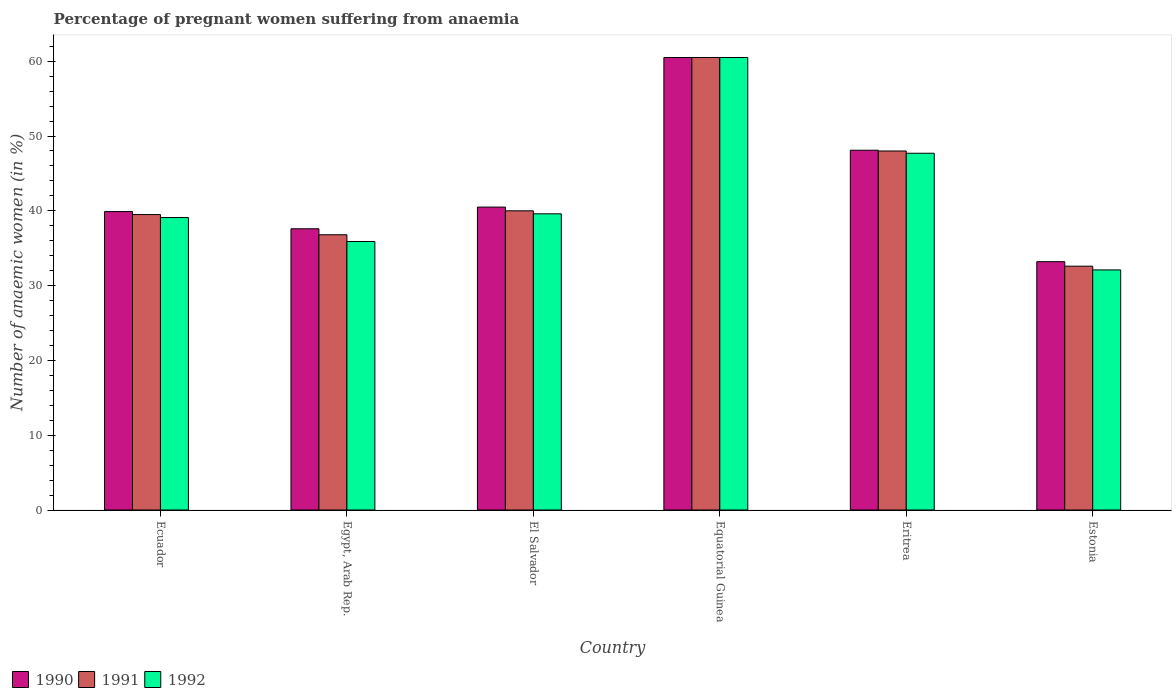How many different coloured bars are there?
Provide a short and direct response. 3. Are the number of bars per tick equal to the number of legend labels?
Ensure brevity in your answer.  Yes. Are the number of bars on each tick of the X-axis equal?
Provide a succinct answer. Yes. How many bars are there on the 2nd tick from the right?
Your response must be concise. 3. What is the label of the 3rd group of bars from the left?
Offer a very short reply. El Salvador. What is the number of anaemic women in 1991 in Egypt, Arab Rep.?
Make the answer very short. 36.8. Across all countries, what is the maximum number of anaemic women in 1992?
Your answer should be compact. 60.5. Across all countries, what is the minimum number of anaemic women in 1992?
Your answer should be compact. 32.1. In which country was the number of anaemic women in 1992 maximum?
Keep it short and to the point. Equatorial Guinea. In which country was the number of anaemic women in 1990 minimum?
Give a very brief answer. Estonia. What is the total number of anaemic women in 1990 in the graph?
Keep it short and to the point. 259.8. What is the difference between the number of anaemic women in 1990 in Ecuador and that in Eritrea?
Provide a succinct answer. -8.2. What is the difference between the number of anaemic women in 1992 in El Salvador and the number of anaemic women in 1991 in Egypt, Arab Rep.?
Make the answer very short. 2.8. What is the average number of anaemic women in 1990 per country?
Your answer should be very brief. 43.3. What is the difference between the number of anaemic women of/in 1990 and number of anaemic women of/in 1992 in Equatorial Guinea?
Your response must be concise. 0. In how many countries, is the number of anaemic women in 1991 greater than 42 %?
Provide a succinct answer. 2. What is the ratio of the number of anaemic women in 1992 in Ecuador to that in Eritrea?
Keep it short and to the point. 0.82. Is the difference between the number of anaemic women in 1990 in Ecuador and Egypt, Arab Rep. greater than the difference between the number of anaemic women in 1992 in Ecuador and Egypt, Arab Rep.?
Give a very brief answer. No. What is the difference between the highest and the second highest number of anaemic women in 1990?
Give a very brief answer. 7.6. What is the difference between the highest and the lowest number of anaemic women in 1991?
Offer a very short reply. 27.9. Is the sum of the number of anaemic women in 1992 in Eritrea and Estonia greater than the maximum number of anaemic women in 1990 across all countries?
Provide a short and direct response. Yes. What does the 1st bar from the left in Egypt, Arab Rep. represents?
Offer a very short reply. 1990. Is it the case that in every country, the sum of the number of anaemic women in 1992 and number of anaemic women in 1991 is greater than the number of anaemic women in 1990?
Make the answer very short. Yes. How many bars are there?
Make the answer very short. 18. What is the difference between two consecutive major ticks on the Y-axis?
Ensure brevity in your answer.  10. Are the values on the major ticks of Y-axis written in scientific E-notation?
Offer a very short reply. No. How many legend labels are there?
Your answer should be compact. 3. What is the title of the graph?
Provide a succinct answer. Percentage of pregnant women suffering from anaemia. Does "1988" appear as one of the legend labels in the graph?
Give a very brief answer. No. What is the label or title of the X-axis?
Your answer should be very brief. Country. What is the label or title of the Y-axis?
Your answer should be very brief. Number of anaemic women (in %). What is the Number of anaemic women (in %) of 1990 in Ecuador?
Offer a very short reply. 39.9. What is the Number of anaemic women (in %) in 1991 in Ecuador?
Give a very brief answer. 39.5. What is the Number of anaemic women (in %) in 1992 in Ecuador?
Offer a very short reply. 39.1. What is the Number of anaemic women (in %) in 1990 in Egypt, Arab Rep.?
Your response must be concise. 37.6. What is the Number of anaemic women (in %) of 1991 in Egypt, Arab Rep.?
Offer a terse response. 36.8. What is the Number of anaemic women (in %) of 1992 in Egypt, Arab Rep.?
Provide a short and direct response. 35.9. What is the Number of anaemic women (in %) of 1990 in El Salvador?
Ensure brevity in your answer.  40.5. What is the Number of anaemic women (in %) of 1991 in El Salvador?
Your response must be concise. 40. What is the Number of anaemic women (in %) in 1992 in El Salvador?
Give a very brief answer. 39.6. What is the Number of anaemic women (in %) of 1990 in Equatorial Guinea?
Ensure brevity in your answer.  60.5. What is the Number of anaemic women (in %) in 1991 in Equatorial Guinea?
Provide a short and direct response. 60.5. What is the Number of anaemic women (in %) of 1992 in Equatorial Guinea?
Give a very brief answer. 60.5. What is the Number of anaemic women (in %) in 1990 in Eritrea?
Your response must be concise. 48.1. What is the Number of anaemic women (in %) in 1991 in Eritrea?
Provide a short and direct response. 48. What is the Number of anaemic women (in %) of 1992 in Eritrea?
Ensure brevity in your answer.  47.7. What is the Number of anaemic women (in %) of 1990 in Estonia?
Provide a succinct answer. 33.2. What is the Number of anaemic women (in %) in 1991 in Estonia?
Give a very brief answer. 32.6. What is the Number of anaemic women (in %) in 1992 in Estonia?
Give a very brief answer. 32.1. Across all countries, what is the maximum Number of anaemic women (in %) of 1990?
Your answer should be compact. 60.5. Across all countries, what is the maximum Number of anaemic women (in %) in 1991?
Provide a succinct answer. 60.5. Across all countries, what is the maximum Number of anaemic women (in %) of 1992?
Keep it short and to the point. 60.5. Across all countries, what is the minimum Number of anaemic women (in %) in 1990?
Offer a terse response. 33.2. Across all countries, what is the minimum Number of anaemic women (in %) in 1991?
Offer a terse response. 32.6. Across all countries, what is the minimum Number of anaemic women (in %) of 1992?
Your response must be concise. 32.1. What is the total Number of anaemic women (in %) of 1990 in the graph?
Provide a succinct answer. 259.8. What is the total Number of anaemic women (in %) of 1991 in the graph?
Ensure brevity in your answer.  257.4. What is the total Number of anaemic women (in %) of 1992 in the graph?
Your answer should be very brief. 254.9. What is the difference between the Number of anaemic women (in %) of 1990 in Ecuador and that in Egypt, Arab Rep.?
Your answer should be compact. 2.3. What is the difference between the Number of anaemic women (in %) of 1990 in Ecuador and that in Equatorial Guinea?
Ensure brevity in your answer.  -20.6. What is the difference between the Number of anaemic women (in %) of 1992 in Ecuador and that in Equatorial Guinea?
Provide a short and direct response. -21.4. What is the difference between the Number of anaemic women (in %) of 1990 in Ecuador and that in Estonia?
Your answer should be compact. 6.7. What is the difference between the Number of anaemic women (in %) in 1992 in Ecuador and that in Estonia?
Provide a succinct answer. 7. What is the difference between the Number of anaemic women (in %) of 1990 in Egypt, Arab Rep. and that in El Salvador?
Your answer should be compact. -2.9. What is the difference between the Number of anaemic women (in %) of 1991 in Egypt, Arab Rep. and that in El Salvador?
Offer a terse response. -3.2. What is the difference between the Number of anaemic women (in %) of 1990 in Egypt, Arab Rep. and that in Equatorial Guinea?
Give a very brief answer. -22.9. What is the difference between the Number of anaemic women (in %) of 1991 in Egypt, Arab Rep. and that in Equatorial Guinea?
Provide a succinct answer. -23.7. What is the difference between the Number of anaemic women (in %) in 1992 in Egypt, Arab Rep. and that in Equatorial Guinea?
Provide a short and direct response. -24.6. What is the difference between the Number of anaemic women (in %) of 1991 in Egypt, Arab Rep. and that in Eritrea?
Ensure brevity in your answer.  -11.2. What is the difference between the Number of anaemic women (in %) in 1992 in Egypt, Arab Rep. and that in Eritrea?
Provide a succinct answer. -11.8. What is the difference between the Number of anaemic women (in %) of 1990 in Egypt, Arab Rep. and that in Estonia?
Your answer should be compact. 4.4. What is the difference between the Number of anaemic women (in %) of 1990 in El Salvador and that in Equatorial Guinea?
Ensure brevity in your answer.  -20. What is the difference between the Number of anaemic women (in %) of 1991 in El Salvador and that in Equatorial Guinea?
Give a very brief answer. -20.5. What is the difference between the Number of anaemic women (in %) in 1992 in El Salvador and that in Equatorial Guinea?
Offer a terse response. -20.9. What is the difference between the Number of anaemic women (in %) in 1990 in El Salvador and that in Estonia?
Provide a succinct answer. 7.3. What is the difference between the Number of anaemic women (in %) of 1991 in El Salvador and that in Estonia?
Provide a succinct answer. 7.4. What is the difference between the Number of anaemic women (in %) of 1992 in El Salvador and that in Estonia?
Make the answer very short. 7.5. What is the difference between the Number of anaemic women (in %) in 1990 in Equatorial Guinea and that in Eritrea?
Give a very brief answer. 12.4. What is the difference between the Number of anaemic women (in %) in 1990 in Equatorial Guinea and that in Estonia?
Your response must be concise. 27.3. What is the difference between the Number of anaemic women (in %) in 1991 in Equatorial Guinea and that in Estonia?
Give a very brief answer. 27.9. What is the difference between the Number of anaemic women (in %) of 1992 in Equatorial Guinea and that in Estonia?
Give a very brief answer. 28.4. What is the difference between the Number of anaemic women (in %) of 1990 in Eritrea and that in Estonia?
Your answer should be very brief. 14.9. What is the difference between the Number of anaemic women (in %) of 1990 in Ecuador and the Number of anaemic women (in %) of 1992 in Egypt, Arab Rep.?
Ensure brevity in your answer.  4. What is the difference between the Number of anaemic women (in %) of 1991 in Ecuador and the Number of anaemic women (in %) of 1992 in Egypt, Arab Rep.?
Provide a succinct answer. 3.6. What is the difference between the Number of anaemic women (in %) in 1990 in Ecuador and the Number of anaemic women (in %) in 1992 in El Salvador?
Make the answer very short. 0.3. What is the difference between the Number of anaemic women (in %) of 1990 in Ecuador and the Number of anaemic women (in %) of 1991 in Equatorial Guinea?
Make the answer very short. -20.6. What is the difference between the Number of anaemic women (in %) in 1990 in Ecuador and the Number of anaemic women (in %) in 1992 in Equatorial Guinea?
Give a very brief answer. -20.6. What is the difference between the Number of anaemic women (in %) in 1990 in Ecuador and the Number of anaemic women (in %) in 1991 in Eritrea?
Your answer should be compact. -8.1. What is the difference between the Number of anaemic women (in %) in 1990 in Ecuador and the Number of anaemic women (in %) in 1992 in Eritrea?
Offer a terse response. -7.8. What is the difference between the Number of anaemic women (in %) in 1990 in Ecuador and the Number of anaemic women (in %) in 1991 in Estonia?
Your response must be concise. 7.3. What is the difference between the Number of anaemic women (in %) in 1990 in Egypt, Arab Rep. and the Number of anaemic women (in %) in 1991 in El Salvador?
Make the answer very short. -2.4. What is the difference between the Number of anaemic women (in %) of 1990 in Egypt, Arab Rep. and the Number of anaemic women (in %) of 1991 in Equatorial Guinea?
Give a very brief answer. -22.9. What is the difference between the Number of anaemic women (in %) in 1990 in Egypt, Arab Rep. and the Number of anaemic women (in %) in 1992 in Equatorial Guinea?
Your answer should be very brief. -22.9. What is the difference between the Number of anaemic women (in %) of 1991 in Egypt, Arab Rep. and the Number of anaemic women (in %) of 1992 in Equatorial Guinea?
Give a very brief answer. -23.7. What is the difference between the Number of anaemic women (in %) in 1990 in Egypt, Arab Rep. and the Number of anaemic women (in %) in 1992 in Eritrea?
Keep it short and to the point. -10.1. What is the difference between the Number of anaemic women (in %) of 1990 in Egypt, Arab Rep. and the Number of anaemic women (in %) of 1991 in Estonia?
Provide a succinct answer. 5. What is the difference between the Number of anaemic women (in %) of 1990 in Egypt, Arab Rep. and the Number of anaemic women (in %) of 1992 in Estonia?
Provide a short and direct response. 5.5. What is the difference between the Number of anaemic women (in %) in 1991 in Egypt, Arab Rep. and the Number of anaemic women (in %) in 1992 in Estonia?
Provide a short and direct response. 4.7. What is the difference between the Number of anaemic women (in %) in 1990 in El Salvador and the Number of anaemic women (in %) in 1991 in Equatorial Guinea?
Give a very brief answer. -20. What is the difference between the Number of anaemic women (in %) in 1990 in El Salvador and the Number of anaemic women (in %) in 1992 in Equatorial Guinea?
Make the answer very short. -20. What is the difference between the Number of anaemic women (in %) in 1991 in El Salvador and the Number of anaemic women (in %) in 1992 in Equatorial Guinea?
Ensure brevity in your answer.  -20.5. What is the difference between the Number of anaemic women (in %) of 1990 in El Salvador and the Number of anaemic women (in %) of 1992 in Estonia?
Ensure brevity in your answer.  8.4. What is the difference between the Number of anaemic women (in %) of 1991 in El Salvador and the Number of anaemic women (in %) of 1992 in Estonia?
Offer a very short reply. 7.9. What is the difference between the Number of anaemic women (in %) in 1990 in Equatorial Guinea and the Number of anaemic women (in %) in 1991 in Eritrea?
Your answer should be very brief. 12.5. What is the difference between the Number of anaemic women (in %) of 1990 in Equatorial Guinea and the Number of anaemic women (in %) of 1991 in Estonia?
Your response must be concise. 27.9. What is the difference between the Number of anaemic women (in %) of 1990 in Equatorial Guinea and the Number of anaemic women (in %) of 1992 in Estonia?
Ensure brevity in your answer.  28.4. What is the difference between the Number of anaemic women (in %) in 1991 in Equatorial Guinea and the Number of anaemic women (in %) in 1992 in Estonia?
Provide a short and direct response. 28.4. What is the difference between the Number of anaemic women (in %) in 1990 in Eritrea and the Number of anaemic women (in %) in 1991 in Estonia?
Ensure brevity in your answer.  15.5. What is the difference between the Number of anaemic women (in %) in 1990 in Eritrea and the Number of anaemic women (in %) in 1992 in Estonia?
Keep it short and to the point. 16. What is the average Number of anaemic women (in %) of 1990 per country?
Your response must be concise. 43.3. What is the average Number of anaemic women (in %) in 1991 per country?
Ensure brevity in your answer.  42.9. What is the average Number of anaemic women (in %) of 1992 per country?
Provide a short and direct response. 42.48. What is the difference between the Number of anaemic women (in %) of 1990 and Number of anaemic women (in %) of 1991 in Egypt, Arab Rep.?
Your response must be concise. 0.8. What is the difference between the Number of anaemic women (in %) of 1990 and Number of anaemic women (in %) of 1992 in Egypt, Arab Rep.?
Provide a short and direct response. 1.7. What is the difference between the Number of anaemic women (in %) in 1990 and Number of anaemic women (in %) in 1991 in El Salvador?
Make the answer very short. 0.5. What is the difference between the Number of anaemic women (in %) in 1991 and Number of anaemic women (in %) in 1992 in El Salvador?
Your response must be concise. 0.4. What is the difference between the Number of anaemic women (in %) of 1990 and Number of anaemic women (in %) of 1991 in Eritrea?
Your answer should be very brief. 0.1. What is the difference between the Number of anaemic women (in %) of 1991 and Number of anaemic women (in %) of 1992 in Eritrea?
Make the answer very short. 0.3. What is the difference between the Number of anaemic women (in %) of 1990 and Number of anaemic women (in %) of 1991 in Estonia?
Keep it short and to the point. 0.6. What is the difference between the Number of anaemic women (in %) of 1991 and Number of anaemic women (in %) of 1992 in Estonia?
Your answer should be very brief. 0.5. What is the ratio of the Number of anaemic women (in %) of 1990 in Ecuador to that in Egypt, Arab Rep.?
Ensure brevity in your answer.  1.06. What is the ratio of the Number of anaemic women (in %) of 1991 in Ecuador to that in Egypt, Arab Rep.?
Offer a very short reply. 1.07. What is the ratio of the Number of anaemic women (in %) of 1992 in Ecuador to that in Egypt, Arab Rep.?
Offer a terse response. 1.09. What is the ratio of the Number of anaemic women (in %) of 1990 in Ecuador to that in El Salvador?
Offer a terse response. 0.99. What is the ratio of the Number of anaemic women (in %) in 1991 in Ecuador to that in El Salvador?
Offer a very short reply. 0.99. What is the ratio of the Number of anaemic women (in %) of 1992 in Ecuador to that in El Salvador?
Give a very brief answer. 0.99. What is the ratio of the Number of anaemic women (in %) in 1990 in Ecuador to that in Equatorial Guinea?
Give a very brief answer. 0.66. What is the ratio of the Number of anaemic women (in %) of 1991 in Ecuador to that in Equatorial Guinea?
Ensure brevity in your answer.  0.65. What is the ratio of the Number of anaemic women (in %) in 1992 in Ecuador to that in Equatorial Guinea?
Your response must be concise. 0.65. What is the ratio of the Number of anaemic women (in %) in 1990 in Ecuador to that in Eritrea?
Provide a succinct answer. 0.83. What is the ratio of the Number of anaemic women (in %) of 1991 in Ecuador to that in Eritrea?
Ensure brevity in your answer.  0.82. What is the ratio of the Number of anaemic women (in %) in 1992 in Ecuador to that in Eritrea?
Offer a very short reply. 0.82. What is the ratio of the Number of anaemic women (in %) of 1990 in Ecuador to that in Estonia?
Offer a very short reply. 1.2. What is the ratio of the Number of anaemic women (in %) in 1991 in Ecuador to that in Estonia?
Provide a short and direct response. 1.21. What is the ratio of the Number of anaemic women (in %) of 1992 in Ecuador to that in Estonia?
Offer a terse response. 1.22. What is the ratio of the Number of anaemic women (in %) in 1990 in Egypt, Arab Rep. to that in El Salvador?
Give a very brief answer. 0.93. What is the ratio of the Number of anaemic women (in %) in 1992 in Egypt, Arab Rep. to that in El Salvador?
Provide a succinct answer. 0.91. What is the ratio of the Number of anaemic women (in %) in 1990 in Egypt, Arab Rep. to that in Equatorial Guinea?
Offer a terse response. 0.62. What is the ratio of the Number of anaemic women (in %) of 1991 in Egypt, Arab Rep. to that in Equatorial Guinea?
Your response must be concise. 0.61. What is the ratio of the Number of anaemic women (in %) of 1992 in Egypt, Arab Rep. to that in Equatorial Guinea?
Your answer should be very brief. 0.59. What is the ratio of the Number of anaemic women (in %) in 1990 in Egypt, Arab Rep. to that in Eritrea?
Your response must be concise. 0.78. What is the ratio of the Number of anaemic women (in %) of 1991 in Egypt, Arab Rep. to that in Eritrea?
Provide a short and direct response. 0.77. What is the ratio of the Number of anaemic women (in %) of 1992 in Egypt, Arab Rep. to that in Eritrea?
Your response must be concise. 0.75. What is the ratio of the Number of anaemic women (in %) in 1990 in Egypt, Arab Rep. to that in Estonia?
Provide a succinct answer. 1.13. What is the ratio of the Number of anaemic women (in %) in 1991 in Egypt, Arab Rep. to that in Estonia?
Ensure brevity in your answer.  1.13. What is the ratio of the Number of anaemic women (in %) of 1992 in Egypt, Arab Rep. to that in Estonia?
Make the answer very short. 1.12. What is the ratio of the Number of anaemic women (in %) of 1990 in El Salvador to that in Equatorial Guinea?
Keep it short and to the point. 0.67. What is the ratio of the Number of anaemic women (in %) of 1991 in El Salvador to that in Equatorial Guinea?
Your response must be concise. 0.66. What is the ratio of the Number of anaemic women (in %) in 1992 in El Salvador to that in Equatorial Guinea?
Your response must be concise. 0.65. What is the ratio of the Number of anaemic women (in %) of 1990 in El Salvador to that in Eritrea?
Ensure brevity in your answer.  0.84. What is the ratio of the Number of anaemic women (in %) of 1991 in El Salvador to that in Eritrea?
Offer a very short reply. 0.83. What is the ratio of the Number of anaemic women (in %) in 1992 in El Salvador to that in Eritrea?
Your answer should be very brief. 0.83. What is the ratio of the Number of anaemic women (in %) of 1990 in El Salvador to that in Estonia?
Offer a very short reply. 1.22. What is the ratio of the Number of anaemic women (in %) of 1991 in El Salvador to that in Estonia?
Offer a very short reply. 1.23. What is the ratio of the Number of anaemic women (in %) of 1992 in El Salvador to that in Estonia?
Your answer should be very brief. 1.23. What is the ratio of the Number of anaemic women (in %) of 1990 in Equatorial Guinea to that in Eritrea?
Your response must be concise. 1.26. What is the ratio of the Number of anaemic women (in %) of 1991 in Equatorial Guinea to that in Eritrea?
Keep it short and to the point. 1.26. What is the ratio of the Number of anaemic women (in %) in 1992 in Equatorial Guinea to that in Eritrea?
Offer a terse response. 1.27. What is the ratio of the Number of anaemic women (in %) of 1990 in Equatorial Guinea to that in Estonia?
Offer a very short reply. 1.82. What is the ratio of the Number of anaemic women (in %) of 1991 in Equatorial Guinea to that in Estonia?
Make the answer very short. 1.86. What is the ratio of the Number of anaemic women (in %) in 1992 in Equatorial Guinea to that in Estonia?
Your answer should be very brief. 1.88. What is the ratio of the Number of anaemic women (in %) in 1990 in Eritrea to that in Estonia?
Offer a very short reply. 1.45. What is the ratio of the Number of anaemic women (in %) of 1991 in Eritrea to that in Estonia?
Make the answer very short. 1.47. What is the ratio of the Number of anaemic women (in %) of 1992 in Eritrea to that in Estonia?
Your answer should be compact. 1.49. What is the difference between the highest and the second highest Number of anaemic women (in %) in 1990?
Offer a terse response. 12.4. What is the difference between the highest and the second highest Number of anaemic women (in %) of 1991?
Provide a short and direct response. 12.5. What is the difference between the highest and the lowest Number of anaemic women (in %) of 1990?
Keep it short and to the point. 27.3. What is the difference between the highest and the lowest Number of anaemic women (in %) of 1991?
Keep it short and to the point. 27.9. What is the difference between the highest and the lowest Number of anaemic women (in %) in 1992?
Provide a succinct answer. 28.4. 